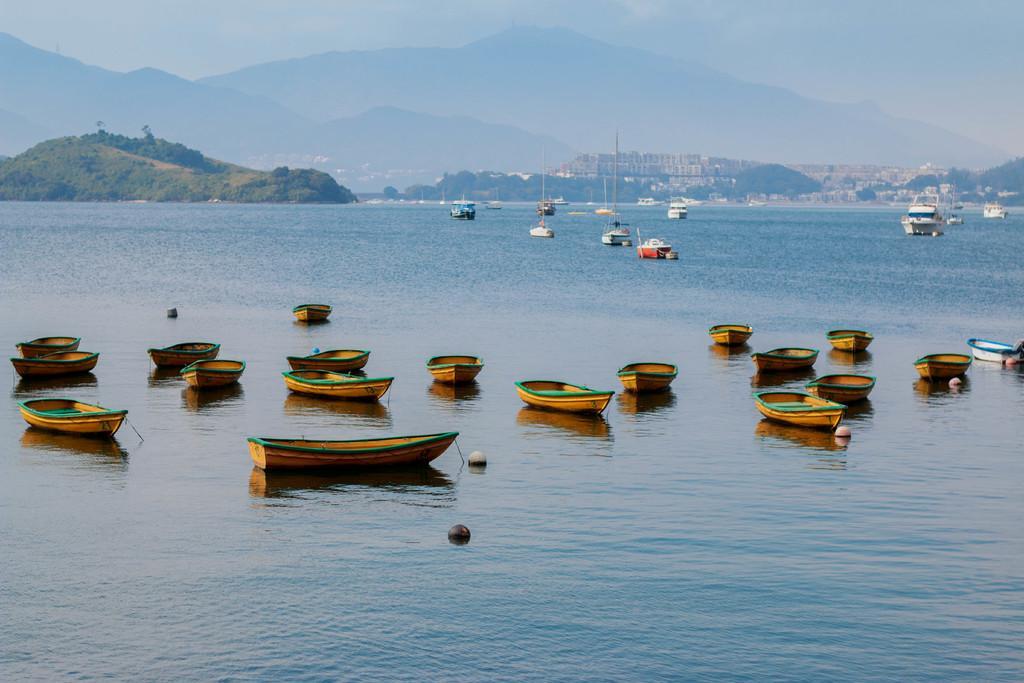Can you describe this image briefly? In this image we can see group of boats placed in water. In the foreground we can see two balls. In the background, we can see a group of buildings, trees, mountains and the sky. 